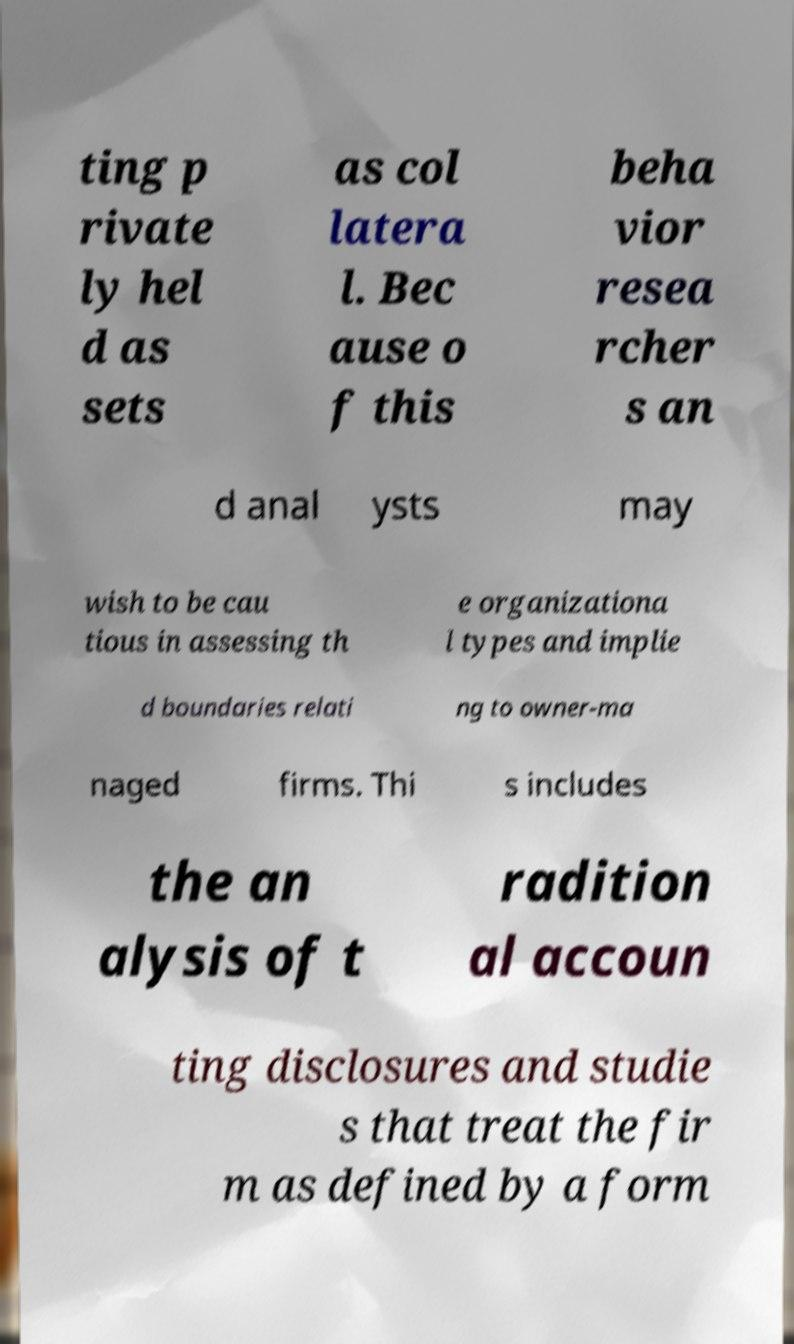Could you extract and type out the text from this image? ting p rivate ly hel d as sets as col latera l. Bec ause o f this beha vior resea rcher s an d anal ysts may wish to be cau tious in assessing th e organizationa l types and implie d boundaries relati ng to owner-ma naged firms. Thi s includes the an alysis of t radition al accoun ting disclosures and studie s that treat the fir m as defined by a form 